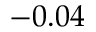<formula> <loc_0><loc_0><loc_500><loc_500>- 0 . 0 4</formula> 